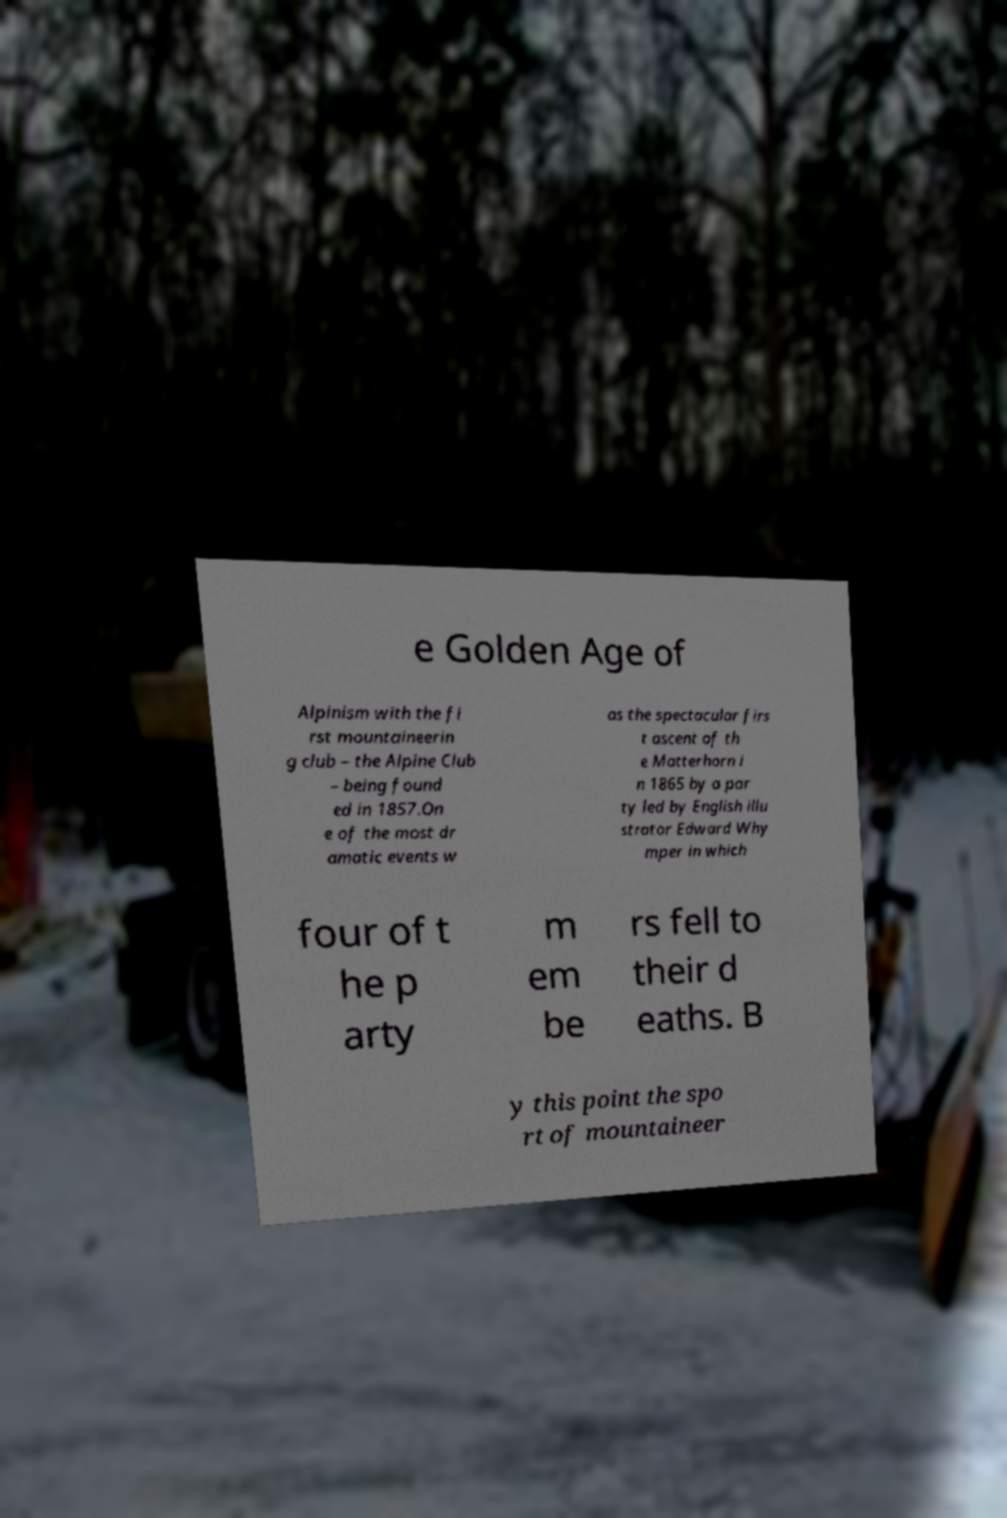There's text embedded in this image that I need extracted. Can you transcribe it verbatim? e Golden Age of Alpinism with the fi rst mountaineerin g club – the Alpine Club – being found ed in 1857.On e of the most dr amatic events w as the spectacular firs t ascent of th e Matterhorn i n 1865 by a par ty led by English illu strator Edward Why mper in which four of t he p arty m em be rs fell to their d eaths. B y this point the spo rt of mountaineer 